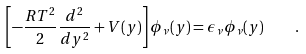Convert formula to latex. <formula><loc_0><loc_0><loc_500><loc_500>\left [ - \frac { R T ^ { 2 } } { 2 } \frac { d ^ { 2 } } { d y ^ { 2 } } + V ( y ) \right ] \phi _ { \nu } ( y ) = \epsilon _ { \nu } \phi _ { \nu } ( y ) \quad .</formula> 